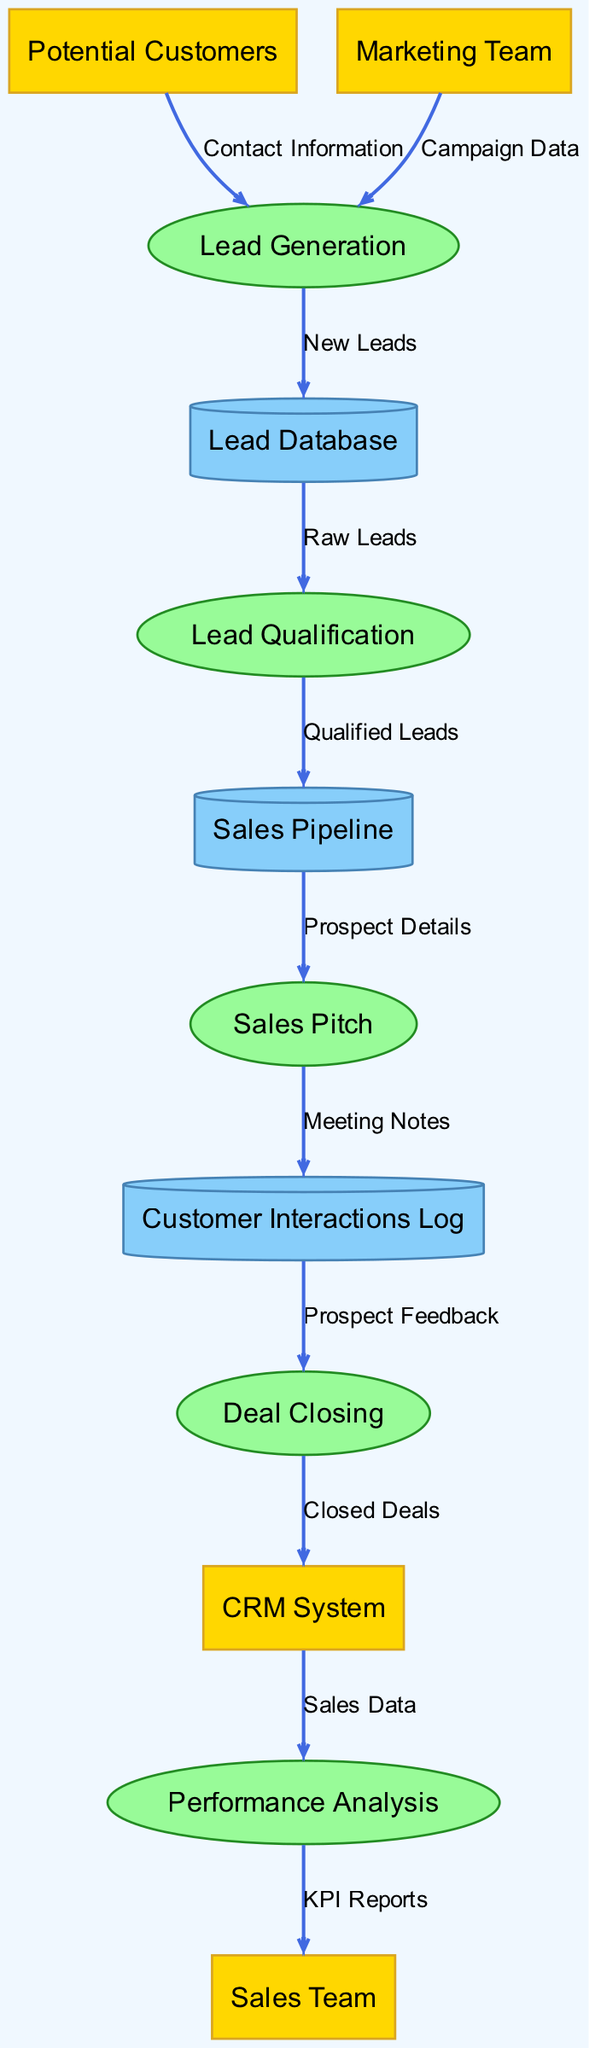What is the first process in the diagram? The first process in the diagram is identified as "Lead Generation," which is the initial action that takes place after potential customers provide their contact information.
Answer: Lead Generation How many external entities are present in the diagram? There are four external entities mentioned in the diagram, which are "Potential Customers," "Marketing Team," "Sales Team," and "CRM System."
Answer: 4 What type of data store is "Lead Database"? The "Lead Database" is a type of data store represented as a cylinder in the diagram, indicating it stores raw leads for processing.
Answer: Cylinder What does "Lead Qualification" send to the "Sales Pipeline"? "Lead Qualification" sends "Qualified Leads" to the "Sales Pipeline," indicating that leads have been assessed and are now ready for sales processes.
Answer: Qualified Leads Which process receives data from "Customer Interactions Log"? The "Deal Closing" process receives data from the "Customer Interactions Log," specifically "Prospect Feedback" which helps in finalizing the deals.
Answer: Deal Closing Which two teams are involved in generating leads? The two teams involved in generating leads are the "Potential Customers" and the "Marketing Team," both of whom provide different types of data to the "Lead Generation" process.
Answer: Potential Customers and Marketing Team How does data flow from "Sales Pitch" to "Customer Interactions Log"? Data flows from "Sales Pitch" to "Customer Interactions Log" through "Meeting Notes," which are recorded after pitching to prospective customers.
Answer: Meeting Notes What type of report does "Performance Analysis" produce for the "Sales Team"? "Performance Analysis" produces "KPI Reports" for the "Sales Team," which summarizes key performance indicators related to sales efforts.
Answer: KPI Reports 